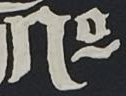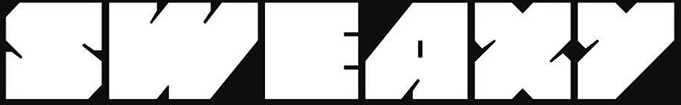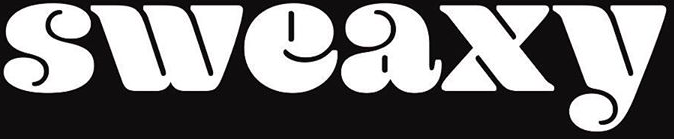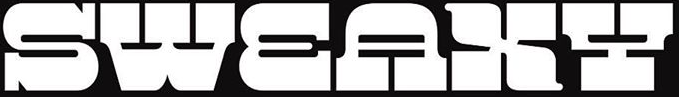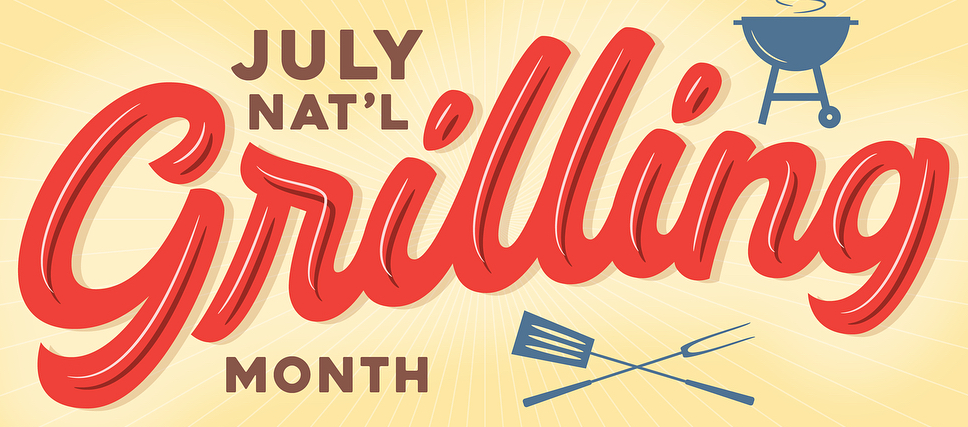Identify the words shown in these images in order, separated by a semicolon. No; SWEAXY; sweaxy; SWEAXY; Grilling 